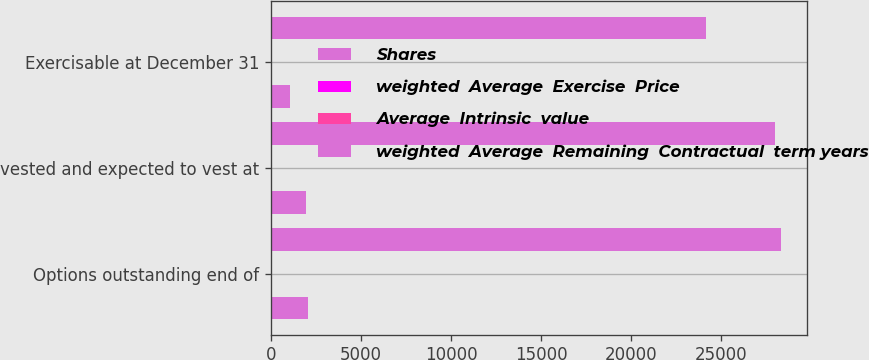<chart> <loc_0><loc_0><loc_500><loc_500><stacked_bar_chart><ecel><fcel>Options outstanding end of<fcel>vested and expected to vest at<fcel>Exercisable at December 31<nl><fcel>Shares<fcel>2034<fcel>1928<fcel>1066<nl><fcel>weighted  Average  Exercise  Price<fcel>64.43<fcel>63.62<fcel>53.17<nl><fcel>Average  Intrinsic  value<fcel>6.3<fcel>6.2<fcel>5.2<nl><fcel>weighted  Average  Remaining  Contractual  term years<fcel>28349<fcel>28006<fcel>24141<nl></chart> 